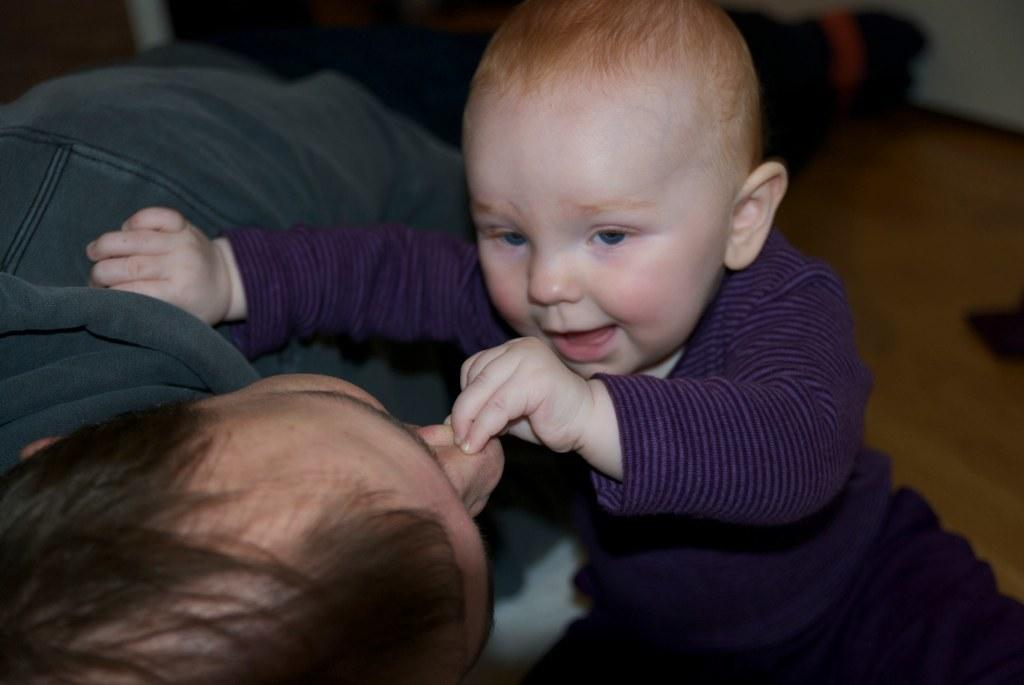What is the main subject of the image? There is a baby in the image. Is there anyone else present in the image? Yes, there is a person in the image. Can you describe the background of the image? The background of the image is blurred. What type of recess can be seen in the image? There is no recess present in the image. Is the baby in the image being held in a prison? There is no indication of a prison or any confinement in the image. 